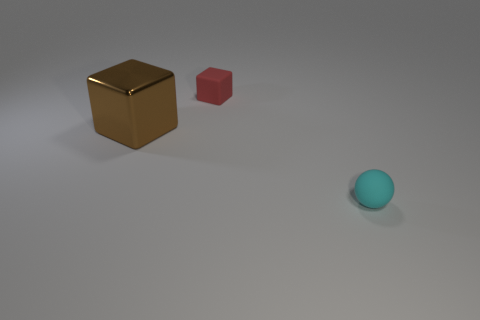Are there any other things that are made of the same material as the big brown cube?
Offer a very short reply. No. How many other things are there of the same material as the large brown cube?
Make the answer very short. 0. How many things are either small cyan objects or small metal things?
Ensure brevity in your answer.  1. The other thing that is the same material as the red thing is what shape?
Provide a short and direct response. Sphere. What number of small objects are either cyan matte objects or matte cubes?
Your answer should be very brief. 2. How many other things are there of the same color as the metallic thing?
Your response must be concise. 0. How many metallic things are in front of the tiny matte thing that is in front of the rubber thing left of the cyan ball?
Give a very brief answer. 0. There is a rubber object behind the cyan thing; is it the same size as the large brown metal block?
Provide a short and direct response. No. Are there fewer tiny rubber blocks that are left of the red matte cube than cyan rubber things behind the small cyan thing?
Offer a very short reply. No. Is the small rubber cube the same color as the small rubber sphere?
Keep it short and to the point. No. 